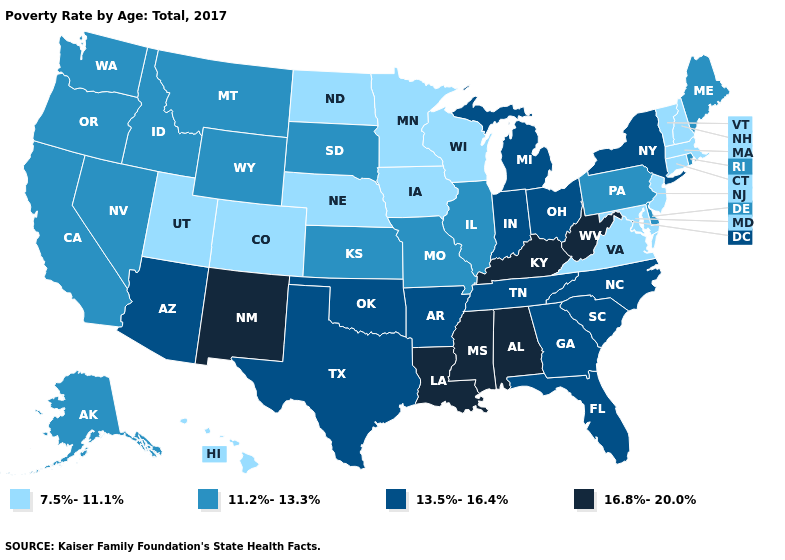What is the highest value in the West ?
Write a very short answer. 16.8%-20.0%. Does Ohio have a lower value than Wisconsin?
Keep it brief. No. How many symbols are there in the legend?
Answer briefly. 4. What is the value of North Dakota?
Keep it brief. 7.5%-11.1%. Does Nevada have the highest value in the West?
Be succinct. No. What is the value of Wyoming?
Be succinct. 11.2%-13.3%. Name the states that have a value in the range 7.5%-11.1%?
Keep it brief. Colorado, Connecticut, Hawaii, Iowa, Maryland, Massachusetts, Minnesota, Nebraska, New Hampshire, New Jersey, North Dakota, Utah, Vermont, Virginia, Wisconsin. Name the states that have a value in the range 7.5%-11.1%?
Keep it brief. Colorado, Connecticut, Hawaii, Iowa, Maryland, Massachusetts, Minnesota, Nebraska, New Hampshire, New Jersey, North Dakota, Utah, Vermont, Virginia, Wisconsin. Does New Hampshire have the lowest value in the Northeast?
Keep it brief. Yes. Does New Mexico have the highest value in the West?
Keep it brief. Yes. Does the map have missing data?
Be succinct. No. Among the states that border Florida , does Alabama have the lowest value?
Concise answer only. No. Name the states that have a value in the range 16.8%-20.0%?
Keep it brief. Alabama, Kentucky, Louisiana, Mississippi, New Mexico, West Virginia. What is the lowest value in the USA?
Write a very short answer. 7.5%-11.1%. 